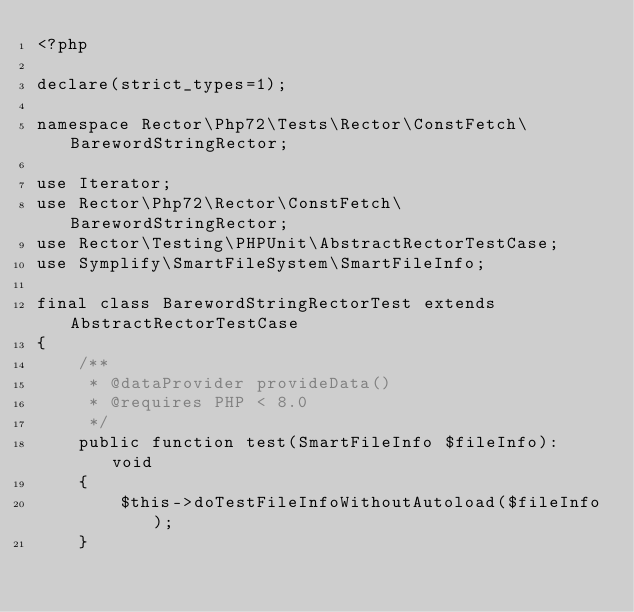<code> <loc_0><loc_0><loc_500><loc_500><_PHP_><?php

declare(strict_types=1);

namespace Rector\Php72\Tests\Rector\ConstFetch\BarewordStringRector;

use Iterator;
use Rector\Php72\Rector\ConstFetch\BarewordStringRector;
use Rector\Testing\PHPUnit\AbstractRectorTestCase;
use Symplify\SmartFileSystem\SmartFileInfo;

final class BarewordStringRectorTest extends AbstractRectorTestCase
{
    /**
     * @dataProvider provideData()
     * @requires PHP < 8.0
     */
    public function test(SmartFileInfo $fileInfo): void
    {
        $this->doTestFileInfoWithoutAutoload($fileInfo);
    }
</code> 